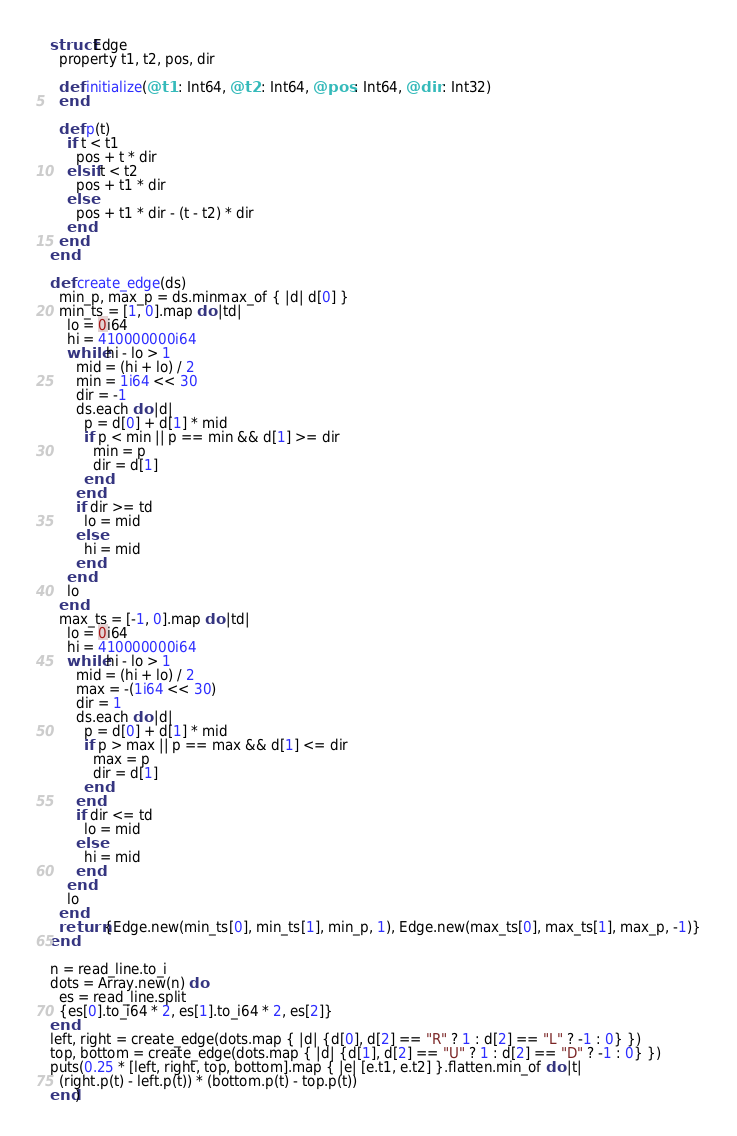<code> <loc_0><loc_0><loc_500><loc_500><_Crystal_>struct Edge
  property t1, t2, pos, dir

  def initialize(@t1 : Int64, @t2 : Int64, @pos : Int64, @dir : Int32)
  end

  def p(t)
    if t < t1
      pos + t * dir
    elsif t < t2
      pos + t1 * dir
    else
      pos + t1 * dir - (t - t2) * dir
    end
  end
end

def create_edge(ds)
  min_p, max_p = ds.minmax_of { |d| d[0] }
  min_ts = [1, 0].map do |td|
    lo = 0i64
    hi = 410000000i64
    while hi - lo > 1
      mid = (hi + lo) / 2
      min = 1i64 << 30
      dir = -1
      ds.each do |d|
        p = d[0] + d[1] * mid
        if p < min || p == min && d[1] >= dir
          min = p
          dir = d[1]
        end
      end
      if dir >= td
        lo = mid
      else
        hi = mid
      end
    end
    lo
  end
  max_ts = [-1, 0].map do |td|
    lo = 0i64
    hi = 410000000i64
    while hi - lo > 1
      mid = (hi + lo) / 2
      max = -(1i64 << 30)
      dir = 1
      ds.each do |d|
        p = d[0] + d[1] * mid
        if p > max || p == max && d[1] <= dir
          max = p
          dir = d[1]
        end
      end
      if dir <= td
        lo = mid
      else
        hi = mid
      end
    end
    lo
  end
  return {Edge.new(min_ts[0], min_ts[1], min_p, 1), Edge.new(max_ts[0], max_ts[1], max_p, -1)}
end

n = read_line.to_i
dots = Array.new(n) do
  es = read_line.split
  {es[0].to_i64 * 2, es[1].to_i64 * 2, es[2]}
end
left, right = create_edge(dots.map { |d| {d[0], d[2] == "R" ? 1 : d[2] == "L" ? -1 : 0} })
top, bottom = create_edge(dots.map { |d| {d[1], d[2] == "U" ? 1 : d[2] == "D" ? -1 : 0} })
puts(0.25 * [left, right, top, bottom].map { |e| [e.t1, e.t2] }.flatten.min_of do |t|
  (right.p(t) - left.p(t)) * (bottom.p(t) - top.p(t))
end)
</code> 